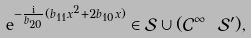<formula> <loc_0><loc_0><loc_500><loc_500>\mathrm e ^ { - \frac { \mathrm i } { b _ { 2 0 } } ( b _ { 1 1 } x ^ { 2 } + 2 b _ { 1 0 } x ) } \in \mathcal { S } \cup ( \mathcal { C } ^ { \infty } \ \mathcal { S } ^ { \prime } ) ,</formula> 